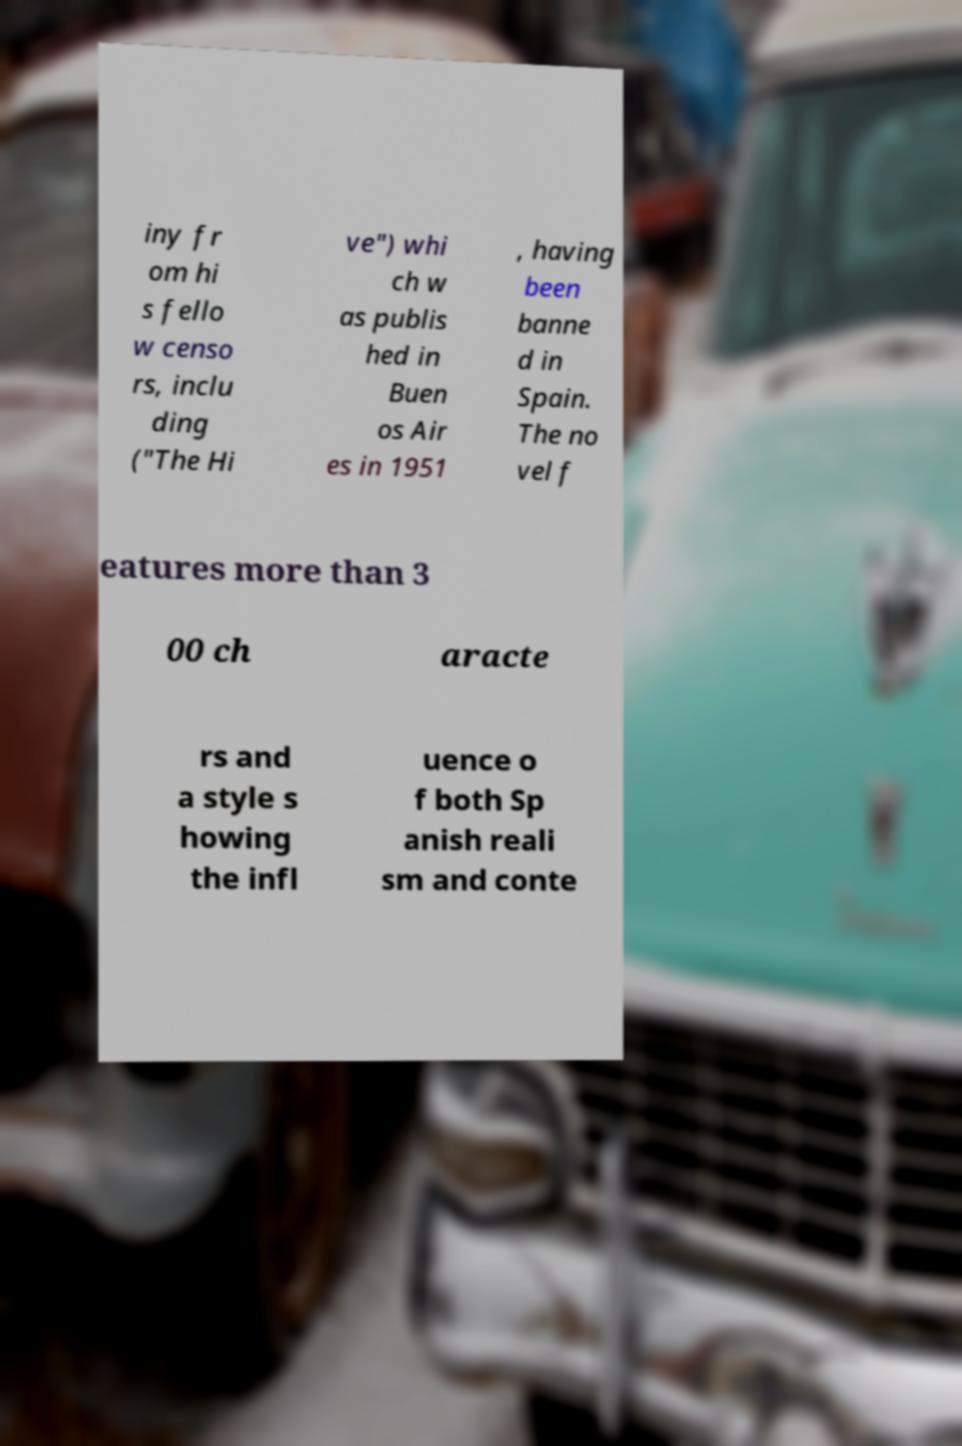What messages or text are displayed in this image? I need them in a readable, typed format. iny fr om hi s fello w censo rs, inclu ding ("The Hi ve") whi ch w as publis hed in Buen os Air es in 1951 , having been banne d in Spain. The no vel f eatures more than 3 00 ch aracte rs and a style s howing the infl uence o f both Sp anish reali sm and conte 